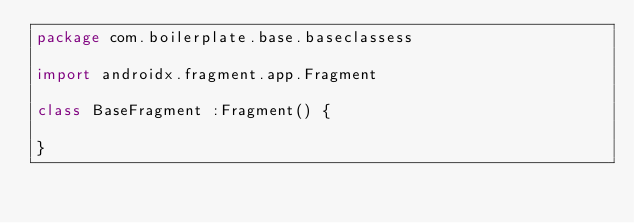Convert code to text. <code><loc_0><loc_0><loc_500><loc_500><_Kotlin_>package com.boilerplate.base.baseclassess

import androidx.fragment.app.Fragment

class BaseFragment :Fragment() {

}</code> 